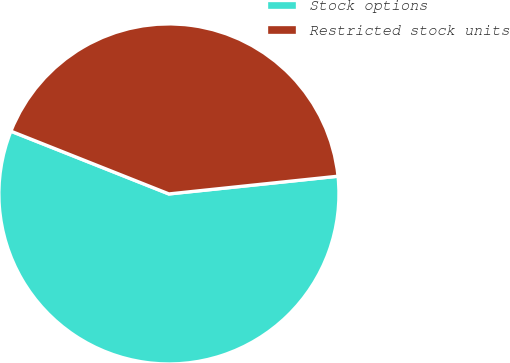<chart> <loc_0><loc_0><loc_500><loc_500><pie_chart><fcel>Stock options<fcel>Restricted stock units<nl><fcel>57.68%<fcel>42.32%<nl></chart> 